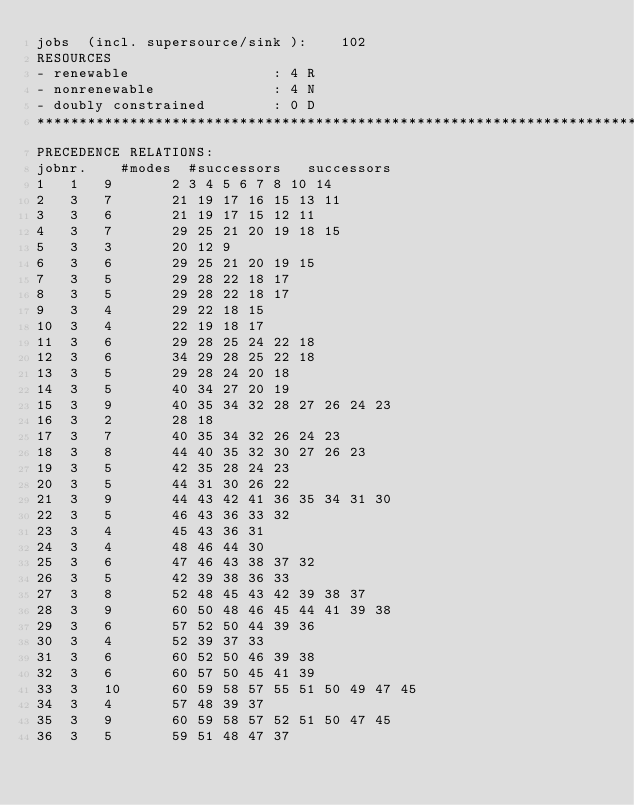<code> <loc_0><loc_0><loc_500><loc_500><_ObjectiveC_>jobs  (incl. supersource/sink ):	102
RESOURCES
- renewable                 : 4 R
- nonrenewable              : 4 N
- doubly constrained        : 0 D
************************************************************************
PRECEDENCE RELATIONS:
jobnr.    #modes  #successors   successors
1	1	9		2 3 4 5 6 7 8 10 14 
2	3	7		21 19 17 16 15 13 11 
3	3	6		21 19 17 15 12 11 
4	3	7		29 25 21 20 19 18 15 
5	3	3		20 12 9 
6	3	6		29 25 21 20 19 15 
7	3	5		29 28 22 18 17 
8	3	5		29 28 22 18 17 
9	3	4		29 22 18 15 
10	3	4		22 19 18 17 
11	3	6		29 28 25 24 22 18 
12	3	6		34 29 28 25 22 18 
13	3	5		29 28 24 20 18 
14	3	5		40 34 27 20 19 
15	3	9		40 35 34 32 28 27 26 24 23 
16	3	2		28 18 
17	3	7		40 35 34 32 26 24 23 
18	3	8		44 40 35 32 30 27 26 23 
19	3	5		42 35 28 24 23 
20	3	5		44 31 30 26 22 
21	3	9		44 43 42 41 36 35 34 31 30 
22	3	5		46 43 36 33 32 
23	3	4		45 43 36 31 
24	3	4		48 46 44 30 
25	3	6		47 46 43 38 37 32 
26	3	5		42 39 38 36 33 
27	3	8		52 48 45 43 42 39 38 37 
28	3	9		60 50 48 46 45 44 41 39 38 
29	3	6		57 52 50 44 39 36 
30	3	4		52 39 37 33 
31	3	6		60 52 50 46 39 38 
32	3	6		60 57 50 45 41 39 
33	3	10		60 59 58 57 55 51 50 49 47 45 
34	3	4		57 48 39 37 
35	3	9		60 59 58 57 52 51 50 47 45 
36	3	5		59 51 48 47 37 </code> 